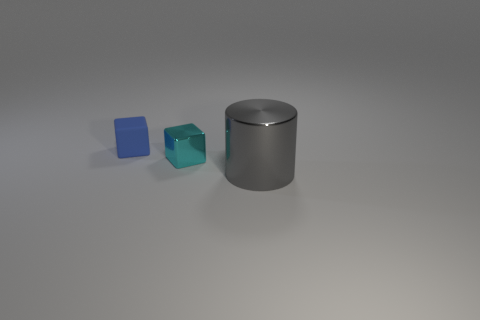Subtract all gray blocks. Subtract all yellow cylinders. How many blocks are left? 2 Add 3 big gray metallic cylinders. How many objects exist? 6 Subtract all cubes. How many objects are left? 1 Subtract 0 green spheres. How many objects are left? 3 Subtract all tiny cyan matte cylinders. Subtract all small matte cubes. How many objects are left? 2 Add 1 big metallic cylinders. How many big metallic cylinders are left? 2 Add 3 small green things. How many small green things exist? 3 